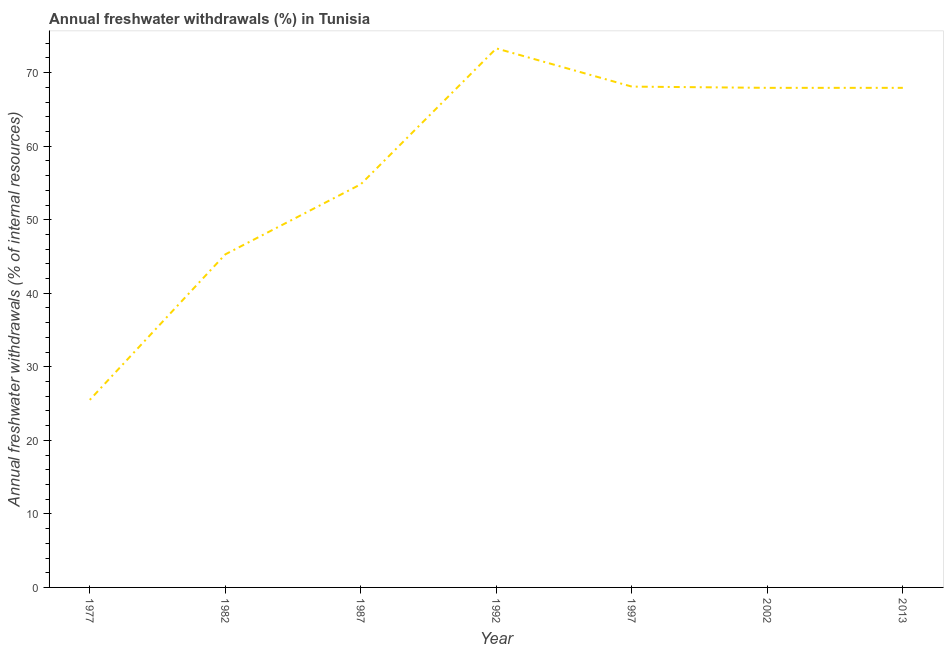What is the annual freshwater withdrawals in 2013?
Ensure brevity in your answer.  67.94. Across all years, what is the maximum annual freshwater withdrawals?
Provide a short and direct response. 73.3. Across all years, what is the minimum annual freshwater withdrawals?
Your answer should be compact. 25.51. In which year was the annual freshwater withdrawals maximum?
Provide a short and direct response. 1992. What is the sum of the annual freshwater withdrawals?
Provide a short and direct response. 402.91. What is the difference between the annual freshwater withdrawals in 1977 and 1992?
Offer a very short reply. -47.79. What is the average annual freshwater withdrawals per year?
Keep it short and to the point. 57.56. What is the median annual freshwater withdrawals?
Offer a very short reply. 67.94. What is the ratio of the annual freshwater withdrawals in 1992 to that in 2013?
Provide a succinct answer. 1.08. What is the difference between the highest and the second highest annual freshwater withdrawals?
Ensure brevity in your answer.  5.2. What is the difference between the highest and the lowest annual freshwater withdrawals?
Make the answer very short. 47.79. How many lines are there?
Give a very brief answer. 1. What is the difference between two consecutive major ticks on the Y-axis?
Give a very brief answer. 10. Are the values on the major ticks of Y-axis written in scientific E-notation?
Your response must be concise. No. Does the graph contain any zero values?
Offer a very short reply. No. What is the title of the graph?
Ensure brevity in your answer.  Annual freshwater withdrawals (%) in Tunisia. What is the label or title of the X-axis?
Make the answer very short. Year. What is the label or title of the Y-axis?
Provide a succinct answer. Annual freshwater withdrawals (% of internal resources). What is the Annual freshwater withdrawals (% of internal resources) of 1977?
Keep it short and to the point. 25.51. What is the Annual freshwater withdrawals (% of internal resources) in 1982?
Keep it short and to the point. 45.29. What is the Annual freshwater withdrawals (% of internal resources) of 1987?
Provide a succinct answer. 54.83. What is the Annual freshwater withdrawals (% of internal resources) in 1992?
Provide a succinct answer. 73.3. What is the Annual freshwater withdrawals (% of internal resources) in 1997?
Provide a succinct answer. 68.1. What is the Annual freshwater withdrawals (% of internal resources) of 2002?
Offer a terse response. 67.94. What is the Annual freshwater withdrawals (% of internal resources) of 2013?
Provide a short and direct response. 67.94. What is the difference between the Annual freshwater withdrawals (% of internal resources) in 1977 and 1982?
Your response must be concise. -19.79. What is the difference between the Annual freshwater withdrawals (% of internal resources) in 1977 and 1987?
Your response must be concise. -29.32. What is the difference between the Annual freshwater withdrawals (% of internal resources) in 1977 and 1992?
Your answer should be very brief. -47.79. What is the difference between the Annual freshwater withdrawals (% of internal resources) in 1977 and 1997?
Ensure brevity in your answer.  -42.6. What is the difference between the Annual freshwater withdrawals (% of internal resources) in 1977 and 2002?
Offer a very short reply. -42.43. What is the difference between the Annual freshwater withdrawals (% of internal resources) in 1977 and 2013?
Offer a terse response. -42.43. What is the difference between the Annual freshwater withdrawals (% of internal resources) in 1982 and 1987?
Give a very brief answer. -9.54. What is the difference between the Annual freshwater withdrawals (% of internal resources) in 1982 and 1992?
Your answer should be compact. -28.01. What is the difference between the Annual freshwater withdrawals (% of internal resources) in 1982 and 1997?
Your answer should be compact. -22.81. What is the difference between the Annual freshwater withdrawals (% of internal resources) in 1982 and 2002?
Your answer should be very brief. -22.65. What is the difference between the Annual freshwater withdrawals (% of internal resources) in 1982 and 2013?
Provide a short and direct response. -22.65. What is the difference between the Annual freshwater withdrawals (% of internal resources) in 1987 and 1992?
Provide a short and direct response. -18.47. What is the difference between the Annual freshwater withdrawals (% of internal resources) in 1987 and 1997?
Your answer should be compact. -13.28. What is the difference between the Annual freshwater withdrawals (% of internal resources) in 1987 and 2002?
Keep it short and to the point. -13.11. What is the difference between the Annual freshwater withdrawals (% of internal resources) in 1987 and 2013?
Make the answer very short. -13.11. What is the difference between the Annual freshwater withdrawals (% of internal resources) in 1992 and 1997?
Offer a very short reply. 5.2. What is the difference between the Annual freshwater withdrawals (% of internal resources) in 1992 and 2002?
Provide a short and direct response. 5.36. What is the difference between the Annual freshwater withdrawals (% of internal resources) in 1992 and 2013?
Keep it short and to the point. 5.36. What is the difference between the Annual freshwater withdrawals (% of internal resources) in 1997 and 2002?
Offer a very short reply. 0.17. What is the difference between the Annual freshwater withdrawals (% of internal resources) in 1997 and 2013?
Provide a succinct answer. 0.17. What is the difference between the Annual freshwater withdrawals (% of internal resources) in 2002 and 2013?
Your answer should be very brief. 0. What is the ratio of the Annual freshwater withdrawals (% of internal resources) in 1977 to that in 1982?
Ensure brevity in your answer.  0.56. What is the ratio of the Annual freshwater withdrawals (% of internal resources) in 1977 to that in 1987?
Offer a terse response. 0.47. What is the ratio of the Annual freshwater withdrawals (% of internal resources) in 1977 to that in 1992?
Give a very brief answer. 0.35. What is the ratio of the Annual freshwater withdrawals (% of internal resources) in 1977 to that in 1997?
Your response must be concise. 0.38. What is the ratio of the Annual freshwater withdrawals (% of internal resources) in 1977 to that in 2013?
Your answer should be compact. 0.38. What is the ratio of the Annual freshwater withdrawals (% of internal resources) in 1982 to that in 1987?
Make the answer very short. 0.83. What is the ratio of the Annual freshwater withdrawals (% of internal resources) in 1982 to that in 1992?
Keep it short and to the point. 0.62. What is the ratio of the Annual freshwater withdrawals (% of internal resources) in 1982 to that in 1997?
Your answer should be very brief. 0.67. What is the ratio of the Annual freshwater withdrawals (% of internal resources) in 1982 to that in 2002?
Your response must be concise. 0.67. What is the ratio of the Annual freshwater withdrawals (% of internal resources) in 1982 to that in 2013?
Make the answer very short. 0.67. What is the ratio of the Annual freshwater withdrawals (% of internal resources) in 1987 to that in 1992?
Provide a short and direct response. 0.75. What is the ratio of the Annual freshwater withdrawals (% of internal resources) in 1987 to that in 1997?
Ensure brevity in your answer.  0.81. What is the ratio of the Annual freshwater withdrawals (% of internal resources) in 1987 to that in 2002?
Ensure brevity in your answer.  0.81. What is the ratio of the Annual freshwater withdrawals (% of internal resources) in 1987 to that in 2013?
Ensure brevity in your answer.  0.81. What is the ratio of the Annual freshwater withdrawals (% of internal resources) in 1992 to that in 1997?
Provide a short and direct response. 1.08. What is the ratio of the Annual freshwater withdrawals (% of internal resources) in 1992 to that in 2002?
Keep it short and to the point. 1.08. What is the ratio of the Annual freshwater withdrawals (% of internal resources) in 1992 to that in 2013?
Your answer should be compact. 1.08. What is the ratio of the Annual freshwater withdrawals (% of internal resources) in 1997 to that in 2013?
Your response must be concise. 1. 